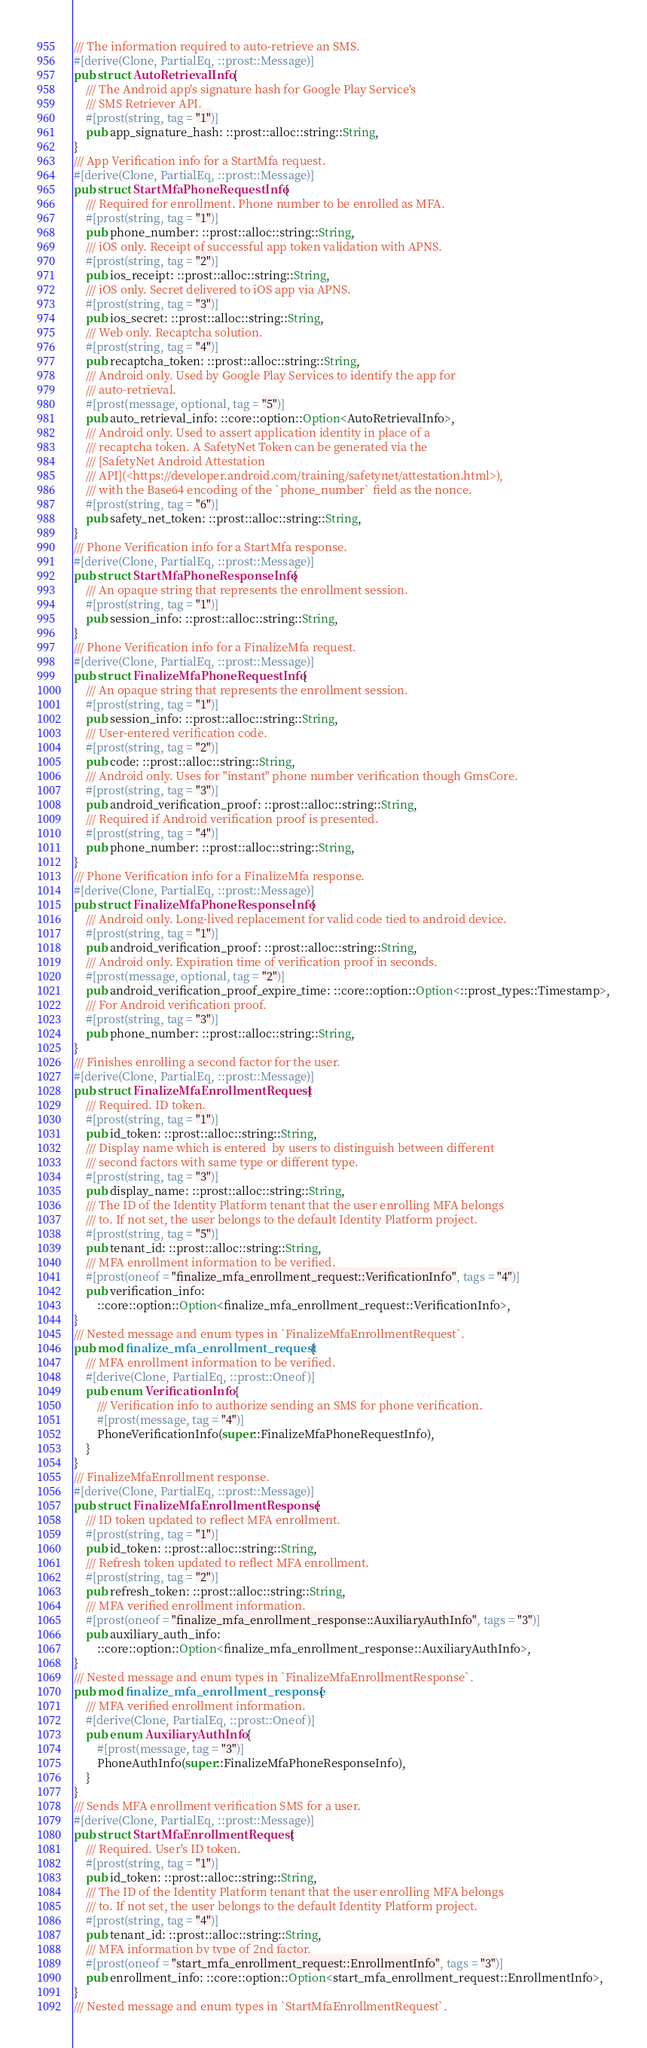Convert code to text. <code><loc_0><loc_0><loc_500><loc_500><_Rust_>/// The information required to auto-retrieve an SMS.
#[derive(Clone, PartialEq, ::prost::Message)]
pub struct AutoRetrievalInfo {
    /// The Android app's signature hash for Google Play Service's
    /// SMS Retriever API.
    #[prost(string, tag = "1")]
    pub app_signature_hash: ::prost::alloc::string::String,
}
/// App Verification info for a StartMfa request.
#[derive(Clone, PartialEq, ::prost::Message)]
pub struct StartMfaPhoneRequestInfo {
    /// Required for enrollment. Phone number to be enrolled as MFA.
    #[prost(string, tag = "1")]
    pub phone_number: ::prost::alloc::string::String,
    /// iOS only. Receipt of successful app token validation with APNS.
    #[prost(string, tag = "2")]
    pub ios_receipt: ::prost::alloc::string::String,
    /// iOS only. Secret delivered to iOS app via APNS.
    #[prost(string, tag = "3")]
    pub ios_secret: ::prost::alloc::string::String,
    /// Web only. Recaptcha solution.
    #[prost(string, tag = "4")]
    pub recaptcha_token: ::prost::alloc::string::String,
    /// Android only. Used by Google Play Services to identify the app for
    /// auto-retrieval.
    #[prost(message, optional, tag = "5")]
    pub auto_retrieval_info: ::core::option::Option<AutoRetrievalInfo>,
    /// Android only. Used to assert application identity in place of a
    /// recaptcha token. A SafetyNet Token can be generated via the
    /// [SafetyNet Android Attestation
    /// API](<https://developer.android.com/training/safetynet/attestation.html>),
    /// with the Base64 encoding of the `phone_number` field as the nonce.
    #[prost(string, tag = "6")]
    pub safety_net_token: ::prost::alloc::string::String,
}
/// Phone Verification info for a StartMfa response.
#[derive(Clone, PartialEq, ::prost::Message)]
pub struct StartMfaPhoneResponseInfo {
    /// An opaque string that represents the enrollment session.
    #[prost(string, tag = "1")]
    pub session_info: ::prost::alloc::string::String,
}
/// Phone Verification info for a FinalizeMfa request.
#[derive(Clone, PartialEq, ::prost::Message)]
pub struct FinalizeMfaPhoneRequestInfo {
    /// An opaque string that represents the enrollment session.
    #[prost(string, tag = "1")]
    pub session_info: ::prost::alloc::string::String,
    /// User-entered verification code.
    #[prost(string, tag = "2")]
    pub code: ::prost::alloc::string::String,
    /// Android only. Uses for "instant" phone number verification though GmsCore.
    #[prost(string, tag = "3")]
    pub android_verification_proof: ::prost::alloc::string::String,
    /// Required if Android verification proof is presented.
    #[prost(string, tag = "4")]
    pub phone_number: ::prost::alloc::string::String,
}
/// Phone Verification info for a FinalizeMfa response.
#[derive(Clone, PartialEq, ::prost::Message)]
pub struct FinalizeMfaPhoneResponseInfo {
    /// Android only. Long-lived replacement for valid code tied to android device.
    #[prost(string, tag = "1")]
    pub android_verification_proof: ::prost::alloc::string::String,
    /// Android only. Expiration time of verification proof in seconds.
    #[prost(message, optional, tag = "2")]
    pub android_verification_proof_expire_time: ::core::option::Option<::prost_types::Timestamp>,
    /// For Android verification proof.
    #[prost(string, tag = "3")]
    pub phone_number: ::prost::alloc::string::String,
}
/// Finishes enrolling a second factor for the user.
#[derive(Clone, PartialEq, ::prost::Message)]
pub struct FinalizeMfaEnrollmentRequest {
    /// Required. ID token.
    #[prost(string, tag = "1")]
    pub id_token: ::prost::alloc::string::String,
    /// Display name which is entered  by users to distinguish between different
    /// second factors with same type or different type.
    #[prost(string, tag = "3")]
    pub display_name: ::prost::alloc::string::String,
    /// The ID of the Identity Platform tenant that the user enrolling MFA belongs
    /// to. If not set, the user belongs to the default Identity Platform project.
    #[prost(string, tag = "5")]
    pub tenant_id: ::prost::alloc::string::String,
    /// MFA enrollment information to be verified.
    #[prost(oneof = "finalize_mfa_enrollment_request::VerificationInfo", tags = "4")]
    pub verification_info:
        ::core::option::Option<finalize_mfa_enrollment_request::VerificationInfo>,
}
/// Nested message and enum types in `FinalizeMfaEnrollmentRequest`.
pub mod finalize_mfa_enrollment_request {
    /// MFA enrollment information to be verified.
    #[derive(Clone, PartialEq, ::prost::Oneof)]
    pub enum VerificationInfo {
        /// Verification info to authorize sending an SMS for phone verification.
        #[prost(message, tag = "4")]
        PhoneVerificationInfo(super::FinalizeMfaPhoneRequestInfo),
    }
}
/// FinalizeMfaEnrollment response.
#[derive(Clone, PartialEq, ::prost::Message)]
pub struct FinalizeMfaEnrollmentResponse {
    /// ID token updated to reflect MFA enrollment.
    #[prost(string, tag = "1")]
    pub id_token: ::prost::alloc::string::String,
    /// Refresh token updated to reflect MFA enrollment.
    #[prost(string, tag = "2")]
    pub refresh_token: ::prost::alloc::string::String,
    /// MFA verified enrollment information.
    #[prost(oneof = "finalize_mfa_enrollment_response::AuxiliaryAuthInfo", tags = "3")]
    pub auxiliary_auth_info:
        ::core::option::Option<finalize_mfa_enrollment_response::AuxiliaryAuthInfo>,
}
/// Nested message and enum types in `FinalizeMfaEnrollmentResponse`.
pub mod finalize_mfa_enrollment_response {
    /// MFA verified enrollment information.
    #[derive(Clone, PartialEq, ::prost::Oneof)]
    pub enum AuxiliaryAuthInfo {
        #[prost(message, tag = "3")]
        PhoneAuthInfo(super::FinalizeMfaPhoneResponseInfo),
    }
}
/// Sends MFA enrollment verification SMS for a user.
#[derive(Clone, PartialEq, ::prost::Message)]
pub struct StartMfaEnrollmentRequest {
    /// Required. User's ID token.
    #[prost(string, tag = "1")]
    pub id_token: ::prost::alloc::string::String,
    /// The ID of the Identity Platform tenant that the user enrolling MFA belongs
    /// to. If not set, the user belongs to the default Identity Platform project.
    #[prost(string, tag = "4")]
    pub tenant_id: ::prost::alloc::string::String,
    /// MFA information by type of 2nd factor.
    #[prost(oneof = "start_mfa_enrollment_request::EnrollmentInfo", tags = "3")]
    pub enrollment_info: ::core::option::Option<start_mfa_enrollment_request::EnrollmentInfo>,
}
/// Nested message and enum types in `StartMfaEnrollmentRequest`.</code> 